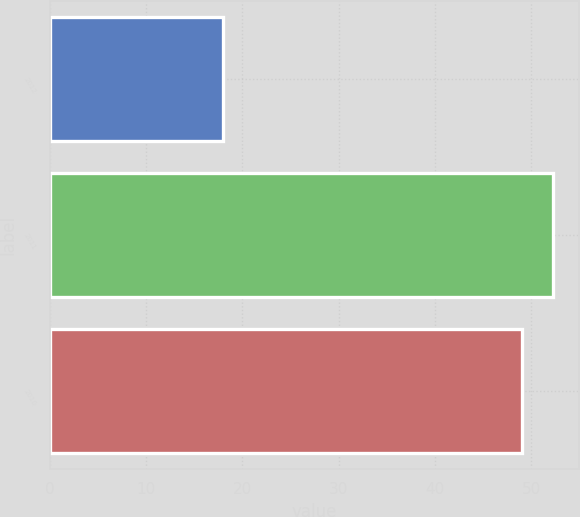Convert chart to OTSL. <chart><loc_0><loc_0><loc_500><loc_500><bar_chart><fcel>2012<fcel>2011<fcel>2010<nl><fcel>18<fcel>52.3<fcel>49<nl></chart> 